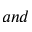<formula> <loc_0><loc_0><loc_500><loc_500>a n d</formula> 